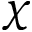Convert formula to latex. <formula><loc_0><loc_0><loc_500><loc_500>\chi</formula> 